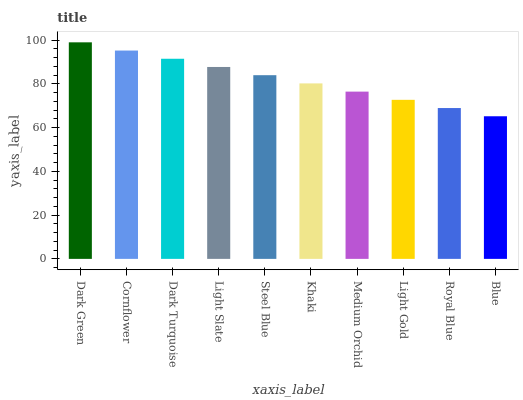Is Blue the minimum?
Answer yes or no. Yes. Is Dark Green the maximum?
Answer yes or no. Yes. Is Cornflower the minimum?
Answer yes or no. No. Is Cornflower the maximum?
Answer yes or no. No. Is Dark Green greater than Cornflower?
Answer yes or no. Yes. Is Cornflower less than Dark Green?
Answer yes or no. Yes. Is Cornflower greater than Dark Green?
Answer yes or no. No. Is Dark Green less than Cornflower?
Answer yes or no. No. Is Steel Blue the high median?
Answer yes or no. Yes. Is Khaki the low median?
Answer yes or no. Yes. Is Dark Turquoise the high median?
Answer yes or no. No. Is Steel Blue the low median?
Answer yes or no. No. 